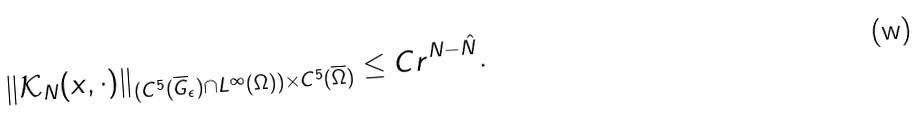Convert formula to latex. <formula><loc_0><loc_0><loc_500><loc_500>\| \mathcal { K } _ { N } ( x , \cdot ) \| _ { ( C ^ { 5 } ( \overline { G } _ { \epsilon } ) \cap L ^ { \infty } ( \Omega ) ) \times C ^ { 5 } ( \overline { \Omega } ) } \leq C r ^ { N - \hat { N } } .</formula> 